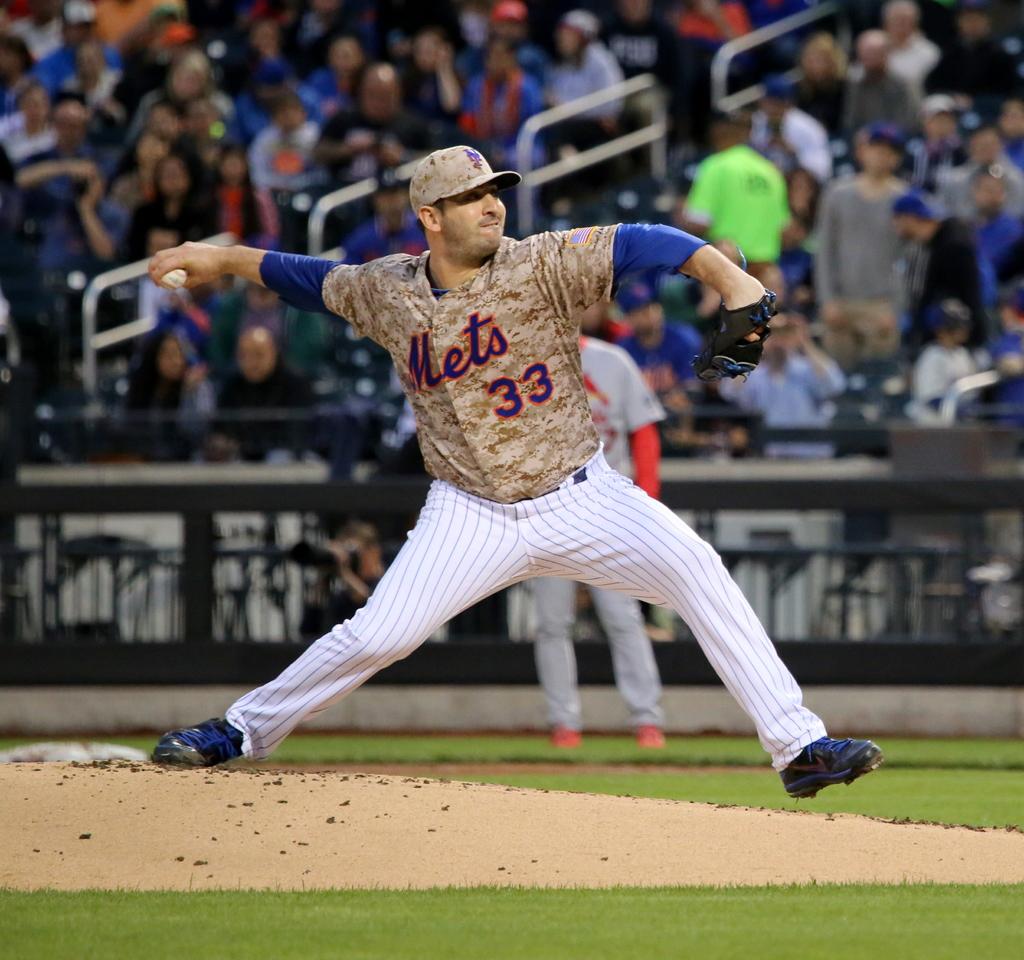What team does he play for?
Make the answer very short. Mets. Which number is he?
Give a very brief answer. 33. 